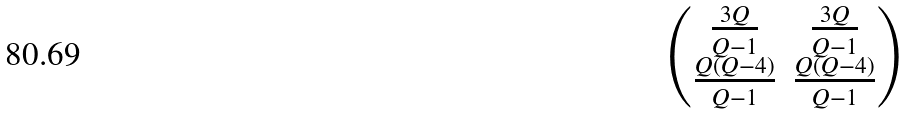Convert formula to latex. <formula><loc_0><loc_0><loc_500><loc_500>\begin{pmatrix} \frac { 3 Q } { Q - 1 } & \frac { 3 Q } { Q - 1 } \\ \frac { Q ( Q - 4 ) } { Q - 1 } & \frac { Q ( Q - 4 ) } { Q - 1 } \end{pmatrix}</formula> 